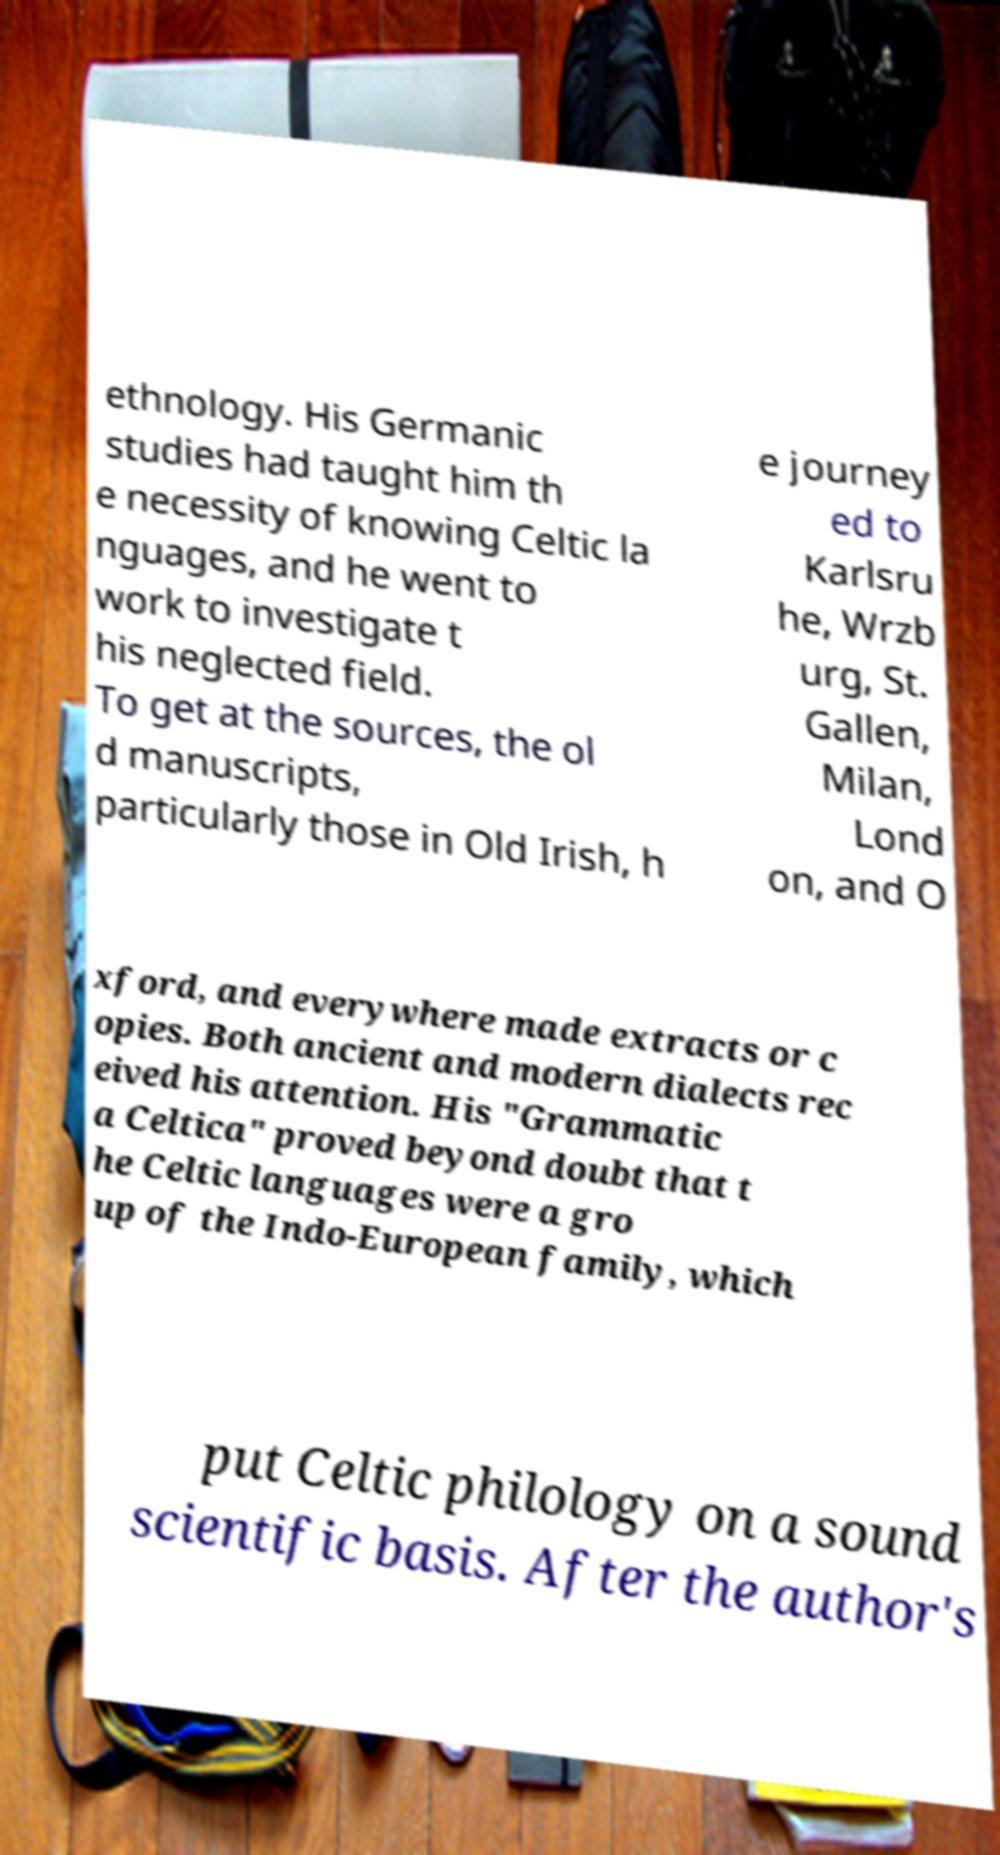Please identify and transcribe the text found in this image. ethnology. His Germanic studies had taught him th e necessity of knowing Celtic la nguages, and he went to work to investigate t his neglected field. To get at the sources, the ol d manuscripts, particularly those in Old Irish, h e journey ed to Karlsru he, Wrzb urg, St. Gallen, Milan, Lond on, and O xford, and everywhere made extracts or c opies. Both ancient and modern dialects rec eived his attention. His "Grammatic a Celtica" proved beyond doubt that t he Celtic languages were a gro up of the Indo-European family, which put Celtic philology on a sound scientific basis. After the author's 